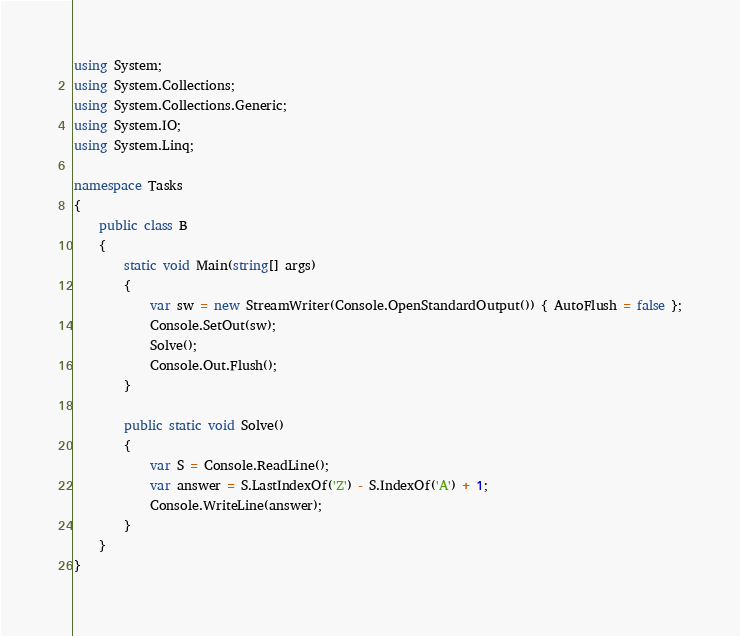Convert code to text. <code><loc_0><loc_0><loc_500><loc_500><_C#_>using System;
using System.Collections;
using System.Collections.Generic;
using System.IO;
using System.Linq;

namespace Tasks
{
    public class B
    {
        static void Main(string[] args)
        {
            var sw = new StreamWriter(Console.OpenStandardOutput()) { AutoFlush = false };
            Console.SetOut(sw);
            Solve();
            Console.Out.Flush();
        }

        public static void Solve()
        {
            var S = Console.ReadLine();
            var answer = S.LastIndexOf('Z') - S.IndexOf('A') + 1;
            Console.WriteLine(answer);
        }
    }
}
</code> 